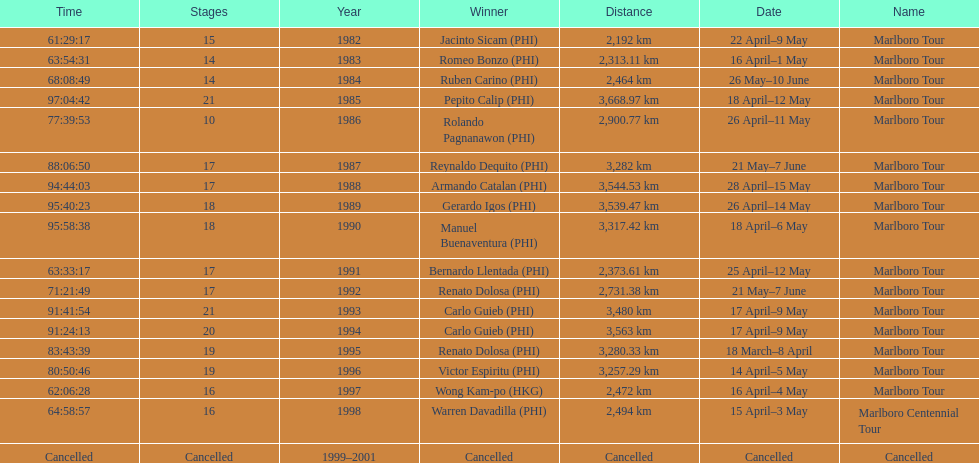How many stages was the 1982 marlboro tour? 15. 